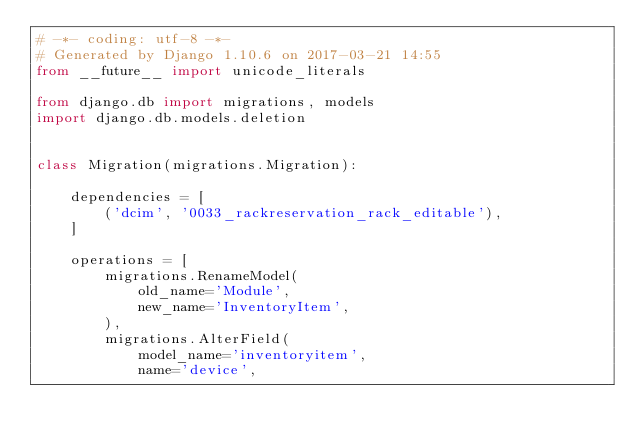Convert code to text. <code><loc_0><loc_0><loc_500><loc_500><_Python_># -*- coding: utf-8 -*-
# Generated by Django 1.10.6 on 2017-03-21 14:55
from __future__ import unicode_literals

from django.db import migrations, models
import django.db.models.deletion


class Migration(migrations.Migration):

    dependencies = [
        ('dcim', '0033_rackreservation_rack_editable'),
    ]

    operations = [
        migrations.RenameModel(
            old_name='Module',
            new_name='InventoryItem',
        ),
        migrations.AlterField(
            model_name='inventoryitem',
            name='device',</code> 